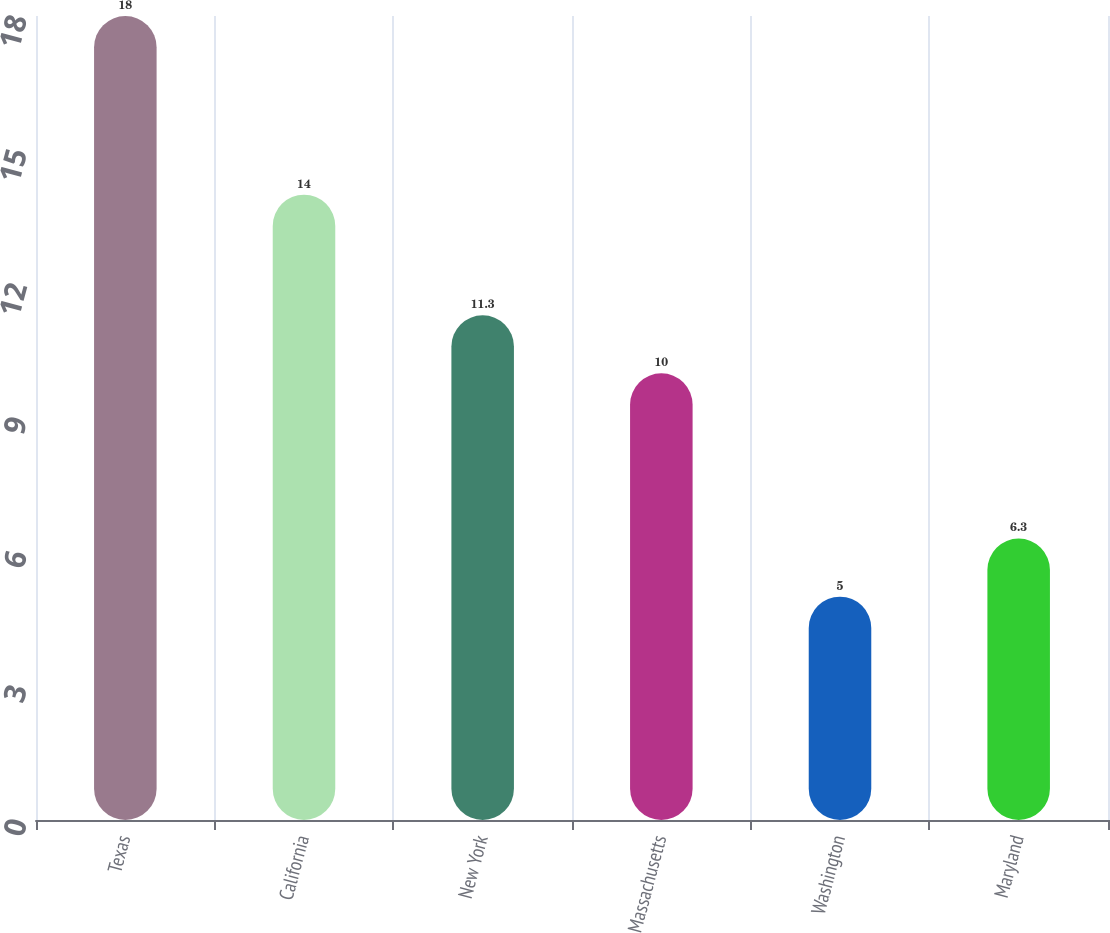Convert chart to OTSL. <chart><loc_0><loc_0><loc_500><loc_500><bar_chart><fcel>Texas<fcel>California<fcel>New York<fcel>Massachusetts<fcel>Washington<fcel>Maryland<nl><fcel>18<fcel>14<fcel>11.3<fcel>10<fcel>5<fcel>6.3<nl></chart> 